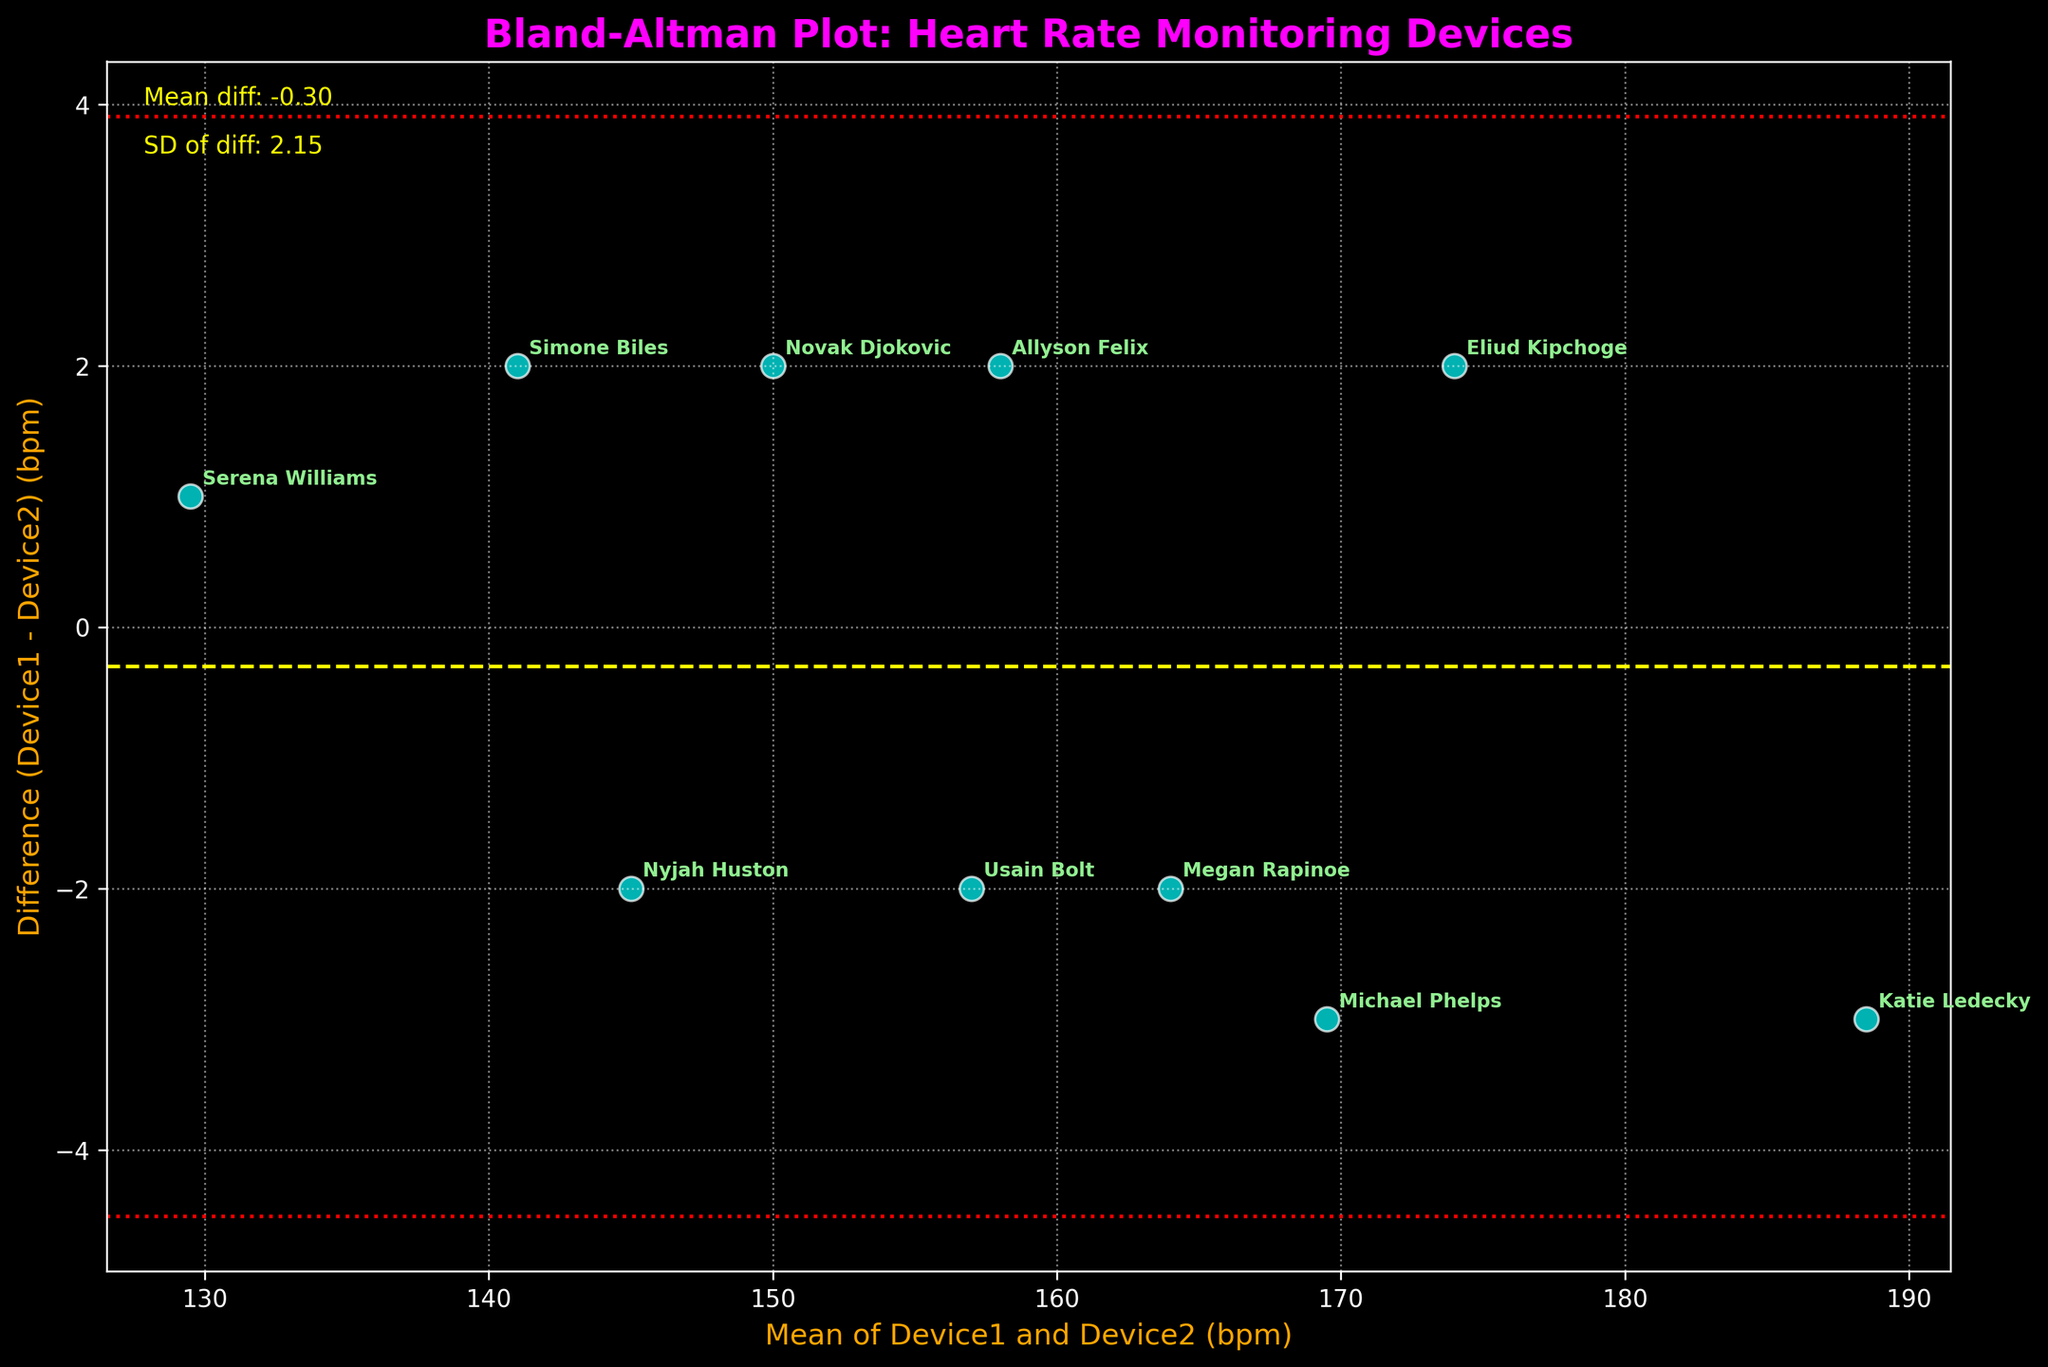what is the title of the plot? The title of the plot is usually found at the top of the figure, styled with a larger and distinct font to grab attention. In this case, it’s clear and readable.
Answer: Bland-Altman Plot: Heart Rate Monitoring Devices what do the x and y axes represent? The x-axis label shows the mean of the heart rates from both devices, and the y-axis label shows the difference between the heart rates recorded by the two devices. This information is presented clearly beside the axes.
Answer: Mean of Device1 and Device2 (bpm), Difference (Device1 - Device2) (bpm) what are the yellow and red lines on the plot? The plot includes dashed and dotted horizontal lines indicating the mean difference (yellow dashed line) and the limits of agreement (red dotted lines). The yellow line represents the average difference between the devices, while the red lines show the typical variability range (mean difference ± 1.96*SD).
Answer: Mean difference, limits of agreement who has the highest heart rate mean during their activity? The highest mean heart rate is identified by finding the point located furthest to the right along the x-axis, annotated by athlete names for clarity. Katie Ledecky’s point at (188.5, -3) is the highest.
Answer: Katie Ledecky which athlete shows the largest positive difference between devices? To find the largest positive difference, we look for the highest point along the y-axis. Michael Phelps's point (169.5, -3) indicates the largest positive difference between Device1 and Device2.
Answer: Michael Phelps is there an athlete whose heart rate measurements are almost identical between the two devices? Identical or nearly identical readings would be close to a y-value of 0. Nyjah Huston’s point near the mean line at (145, -2) shows a minimal difference in heart rates recorded by the devices.
Answer: Nyjah Huston what does the dotted red line above and below the mean difference represent? These lines illustrate the limits of agreement, demarcating the boundary where 95% of the differences between the device readings are expected to fall, based on the standard deviation (SD) from the mean difference.
Answer: Limits of agreement (mean +/− 1.96*SD) which athlete's data falls outside the limits of agreement, if any? To determine if any athlete's data falls outside the red lines, we look for any points beyond these limits vertically. All the data points lie within the dashed red lines.
Answer: None what is the mean difference value between Device1 and Device2 heart rate measurements? The mean difference is indicated by the position of the yellow dashed line and is also textually noted on the plot. It reads ‘Mean diff: -1.2’.
Answer: -1.2 what can you infer from the majority of athletes' data points being evenly distributed around the mean difference line? The even distribution of points around the mean difference indicates consistent performance between Device1 and Device2, suggesting neither device consistently overestimates nor underestimates heart rate measurements.
Answer: Consistent performance between devices 